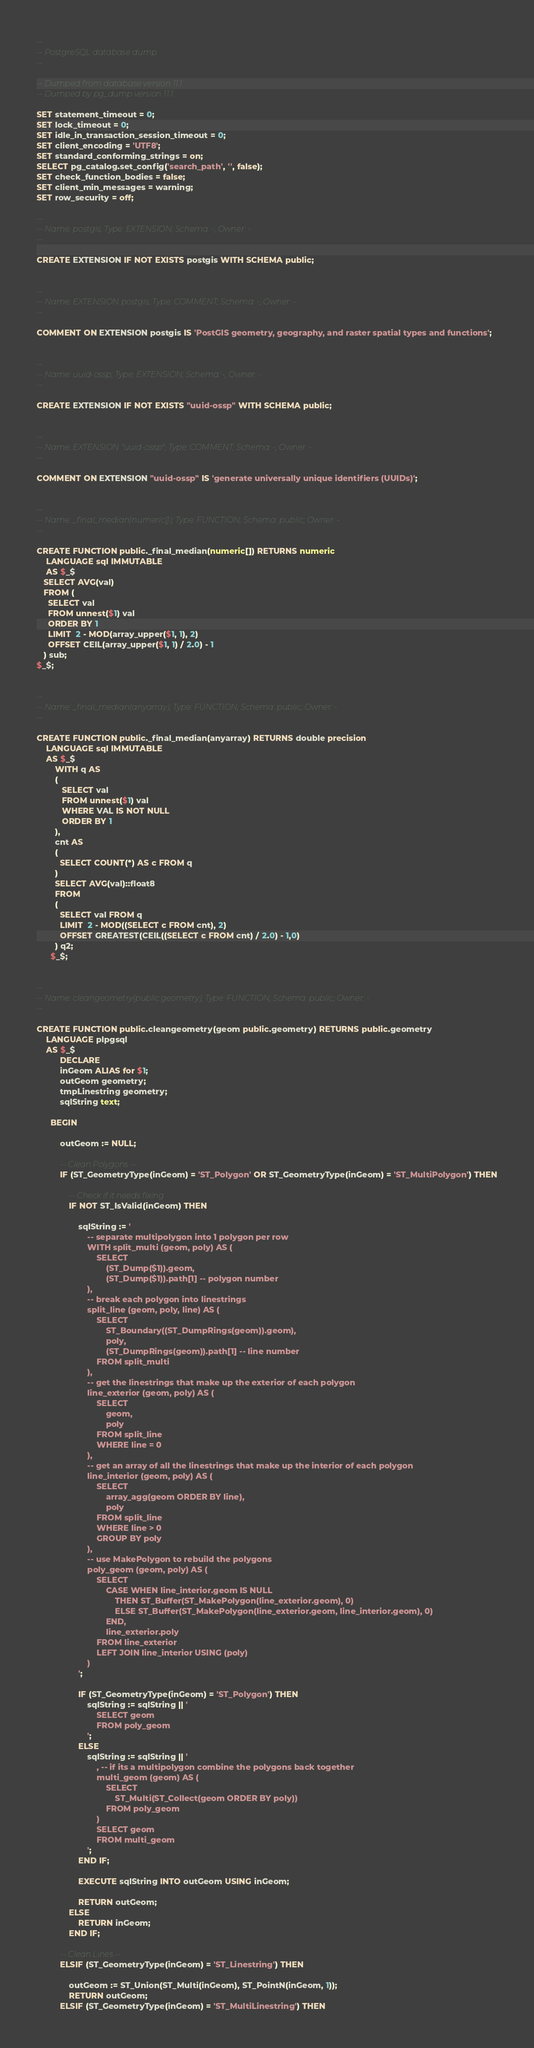Convert code to text. <code><loc_0><loc_0><loc_500><loc_500><_SQL_>--
-- PostgreSQL database dump
--

-- Dumped from database version 11.1
-- Dumped by pg_dump version 11.1

SET statement_timeout = 0;
SET lock_timeout = 0;
SET idle_in_transaction_session_timeout = 0;
SET client_encoding = 'UTF8';
SET standard_conforming_strings = on;
SELECT pg_catalog.set_config('search_path', '', false);
SET check_function_bodies = false;
SET client_min_messages = warning;
SET row_security = off;

--
-- Name: postgis; Type: EXTENSION; Schema: -; Owner: -
--

CREATE EXTENSION IF NOT EXISTS postgis WITH SCHEMA public;


--
-- Name: EXTENSION postgis; Type: COMMENT; Schema: -; Owner: -
--

COMMENT ON EXTENSION postgis IS 'PostGIS geometry, geography, and raster spatial types and functions';


--
-- Name: uuid-ossp; Type: EXTENSION; Schema: -; Owner: -
--

CREATE EXTENSION IF NOT EXISTS "uuid-ossp" WITH SCHEMA public;


--
-- Name: EXTENSION "uuid-ossp"; Type: COMMENT; Schema: -; Owner: -
--

COMMENT ON EXTENSION "uuid-ossp" IS 'generate universally unique identifiers (UUIDs)';


--
-- Name: _final_median(numeric[]); Type: FUNCTION; Schema: public; Owner: -
--

CREATE FUNCTION public._final_median(numeric[]) RETURNS numeric
    LANGUAGE sql IMMUTABLE
    AS $_$
   SELECT AVG(val)
   FROM (
     SELECT val
     FROM unnest($1) val
     ORDER BY 1
     LIMIT  2 - MOD(array_upper($1, 1), 2)
     OFFSET CEIL(array_upper($1, 1) / 2.0) - 1
   ) sub;
$_$;


--
-- Name: _final_median(anyarray); Type: FUNCTION; Schema: public; Owner: -
--

CREATE FUNCTION public._final_median(anyarray) RETURNS double precision
    LANGUAGE sql IMMUTABLE
    AS $_$ 
        WITH q AS
        (
           SELECT val
           FROM unnest($1) val
           WHERE VAL IS NOT NULL
           ORDER BY 1
        ),
        cnt AS
        (
          SELECT COUNT(*) AS c FROM q
        )
        SELECT AVG(val)::float8
        FROM 
        (
          SELECT val FROM q
          LIMIT  2 - MOD((SELECT c FROM cnt), 2)
          OFFSET GREATEST(CEIL((SELECT c FROM cnt) / 2.0) - 1,0)  
        ) q2;
      $_$;


--
-- Name: cleangeometry(public.geometry); Type: FUNCTION; Schema: public; Owner: -
--

CREATE FUNCTION public.cleangeometry(geom public.geometry) RETURNS public.geometry
    LANGUAGE plpgsql
    AS $_$
          DECLARE
          inGeom ALIAS for $1;
          outGeom geometry;
          tmpLinestring geometry;
          sqlString text;

      BEGIN

          outGeom := NULL;

          -- Clean Polygons --
          IF (ST_GeometryType(inGeom) = 'ST_Polygon' OR ST_GeometryType(inGeom) = 'ST_MultiPolygon') THEN

              -- Check if it needs fixing
              IF NOT ST_IsValid(inGeom) THEN

                  sqlString := '
                      -- separate multipolygon into 1 polygon per row
                      WITH split_multi (geom, poly) AS (
                          SELECT
                              (ST_Dump($1)).geom,
                              (ST_Dump($1)).path[1] -- polygon number
                      ),
                      -- break each polygon into linestrings
                      split_line (geom, poly, line) AS (
                          SELECT
                              ST_Boundary((ST_DumpRings(geom)).geom),
                              poly,
                              (ST_DumpRings(geom)).path[1] -- line number
                          FROM split_multi
                      ),
                      -- get the linestrings that make up the exterior of each polygon
                      line_exterior (geom, poly) AS (
                          SELECT
                              geom,
                              poly
                          FROM split_line
                          WHERE line = 0
                      ),
                      -- get an array of all the linestrings that make up the interior of each polygon
                      line_interior (geom, poly) AS (
                          SELECT
                              array_agg(geom ORDER BY line),
                              poly
                          FROM split_line
                          WHERE line > 0
                          GROUP BY poly
                      ),
                      -- use MakePolygon to rebuild the polygons
                      poly_geom (geom, poly) AS (
                          SELECT
                              CASE WHEN line_interior.geom IS NULL
                                  THEN ST_Buffer(ST_MakePolygon(line_exterior.geom), 0)
                                  ELSE ST_Buffer(ST_MakePolygon(line_exterior.geom, line_interior.geom), 0)
                              END,
                              line_exterior.poly
                          FROM line_exterior
                          LEFT JOIN line_interior USING (poly)
                      )
                  ';

                  IF (ST_GeometryType(inGeom) = 'ST_Polygon') THEN
                      sqlString := sqlString || '
                          SELECT geom
                          FROM poly_geom
                      ';
                  ELSE
                      sqlString := sqlString || '
                          , -- if its a multipolygon combine the polygons back together
                          multi_geom (geom) AS (
                              SELECT
                                  ST_Multi(ST_Collect(geom ORDER BY poly))
                              FROM poly_geom
                          )
                          SELECT geom
                          FROM multi_geom
                      ';
                  END IF;

                  EXECUTE sqlString INTO outGeom USING inGeom;

                  RETURN outGeom;
              ELSE
                  RETURN inGeom;
              END IF;

          -- Clean Lines --
          ELSIF (ST_GeometryType(inGeom) = 'ST_Linestring') THEN

              outGeom := ST_Union(ST_Multi(inGeom), ST_PointN(inGeom, 1));
              RETURN outGeom;
          ELSIF (ST_GeometryType(inGeom) = 'ST_MultiLinestring') THEN</code> 